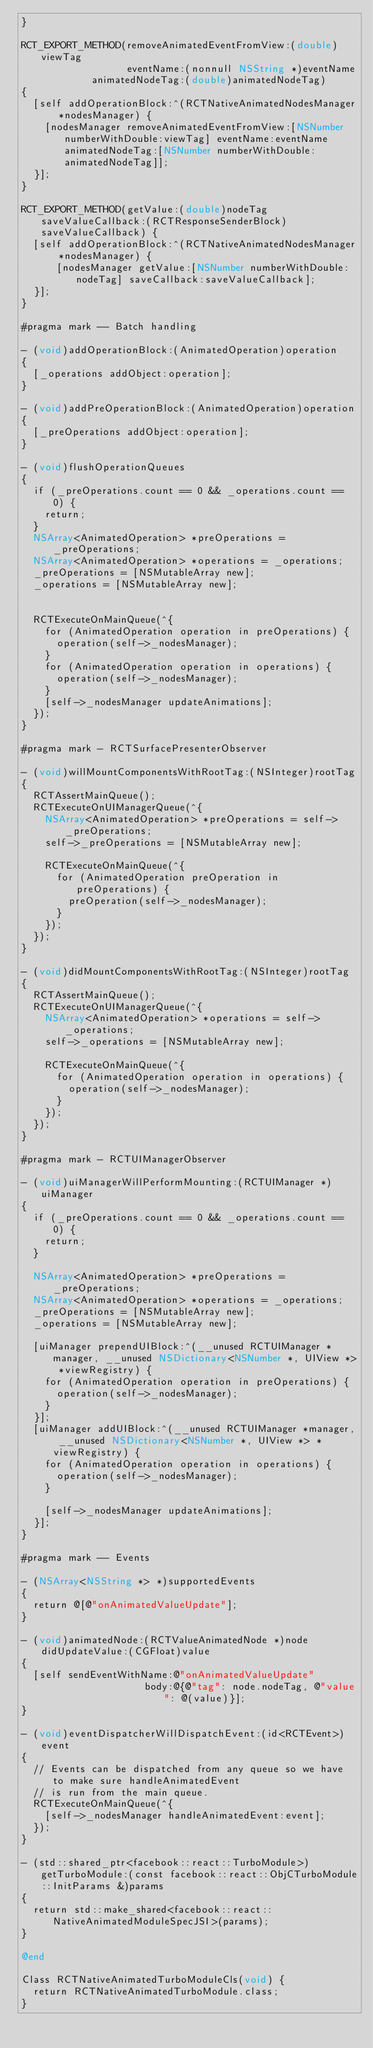Convert code to text. <code><loc_0><loc_0><loc_500><loc_500><_ObjectiveC_>}

RCT_EXPORT_METHOD(removeAnimatedEventFromView:(double)viewTag
                  eventName:(nonnull NSString *)eventName
            animatedNodeTag:(double)animatedNodeTag)
{
  [self addOperationBlock:^(RCTNativeAnimatedNodesManager *nodesManager) {
    [nodesManager removeAnimatedEventFromView:[NSNumber numberWithDouble:viewTag] eventName:eventName animatedNodeTag:[NSNumber numberWithDouble:animatedNodeTag]];
  }];
}

RCT_EXPORT_METHOD(getValue:(double)nodeTag saveValueCallback:(RCTResponseSenderBlock)saveValueCallback) {
  [self addOperationBlock:^(RCTNativeAnimatedNodesManager *nodesManager) {
      [nodesManager getValue:[NSNumber numberWithDouble:nodeTag] saveCallback:saveValueCallback];
  }];
}

#pragma mark -- Batch handling

- (void)addOperationBlock:(AnimatedOperation)operation
{
  [_operations addObject:operation];
}

- (void)addPreOperationBlock:(AnimatedOperation)operation
{
  [_preOperations addObject:operation];
}

- (void)flushOperationQueues
{
  if (_preOperations.count == 0 && _operations.count == 0) {
    return;
  }
  NSArray<AnimatedOperation> *preOperations = _preOperations;
  NSArray<AnimatedOperation> *operations = _operations;
  _preOperations = [NSMutableArray new];
  _operations = [NSMutableArray new];


  RCTExecuteOnMainQueue(^{
    for (AnimatedOperation operation in preOperations) {
      operation(self->_nodesManager);
    }
    for (AnimatedOperation operation in operations) {
      operation(self->_nodesManager);
    }
    [self->_nodesManager updateAnimations];
  });
}

#pragma mark - RCTSurfacePresenterObserver

- (void)willMountComponentsWithRootTag:(NSInteger)rootTag
{
  RCTAssertMainQueue();
  RCTExecuteOnUIManagerQueue(^{
    NSArray<AnimatedOperation> *preOperations = self->_preOperations;
    self->_preOperations = [NSMutableArray new];

    RCTExecuteOnMainQueue(^{
      for (AnimatedOperation preOperation in preOperations) {
        preOperation(self->_nodesManager);
      }
    });
  });
}

- (void)didMountComponentsWithRootTag:(NSInteger)rootTag
{
  RCTAssertMainQueue();
  RCTExecuteOnUIManagerQueue(^{
    NSArray<AnimatedOperation> *operations = self->_operations;
    self->_operations = [NSMutableArray new];

    RCTExecuteOnMainQueue(^{
      for (AnimatedOperation operation in operations) {
        operation(self->_nodesManager);
      }
    });
  });
}

#pragma mark - RCTUIManagerObserver

- (void)uiManagerWillPerformMounting:(RCTUIManager *)uiManager
{
  if (_preOperations.count == 0 && _operations.count == 0) {
    return;
  }

  NSArray<AnimatedOperation> *preOperations = _preOperations;
  NSArray<AnimatedOperation> *operations = _operations;
  _preOperations = [NSMutableArray new];
  _operations = [NSMutableArray new];

  [uiManager prependUIBlock:^(__unused RCTUIManager *manager, __unused NSDictionary<NSNumber *, UIView *> *viewRegistry) {
    for (AnimatedOperation operation in preOperations) {
      operation(self->_nodesManager);
    }
  }];
  [uiManager addUIBlock:^(__unused RCTUIManager *manager, __unused NSDictionary<NSNumber *, UIView *> *viewRegistry) {
    for (AnimatedOperation operation in operations) {
      operation(self->_nodesManager);
    }

    [self->_nodesManager updateAnimations];
  }];
}

#pragma mark -- Events

- (NSArray<NSString *> *)supportedEvents
{
  return @[@"onAnimatedValueUpdate"];
}

- (void)animatedNode:(RCTValueAnimatedNode *)node didUpdateValue:(CGFloat)value
{
  [self sendEventWithName:@"onAnimatedValueUpdate"
                     body:@{@"tag": node.nodeTag, @"value": @(value)}];
}

- (void)eventDispatcherWillDispatchEvent:(id<RCTEvent>)event
{
  // Events can be dispatched from any queue so we have to make sure handleAnimatedEvent
  // is run from the main queue.
  RCTExecuteOnMainQueue(^{
    [self->_nodesManager handleAnimatedEvent:event];
  });
}

- (std::shared_ptr<facebook::react::TurboModule>)getTurboModule:(const facebook::react::ObjCTurboModule::InitParams &)params
{
  return std::make_shared<facebook::react::NativeAnimatedModuleSpecJSI>(params);
}

@end

Class RCTNativeAnimatedTurboModuleCls(void) {
  return RCTNativeAnimatedTurboModule.class;
}
</code> 